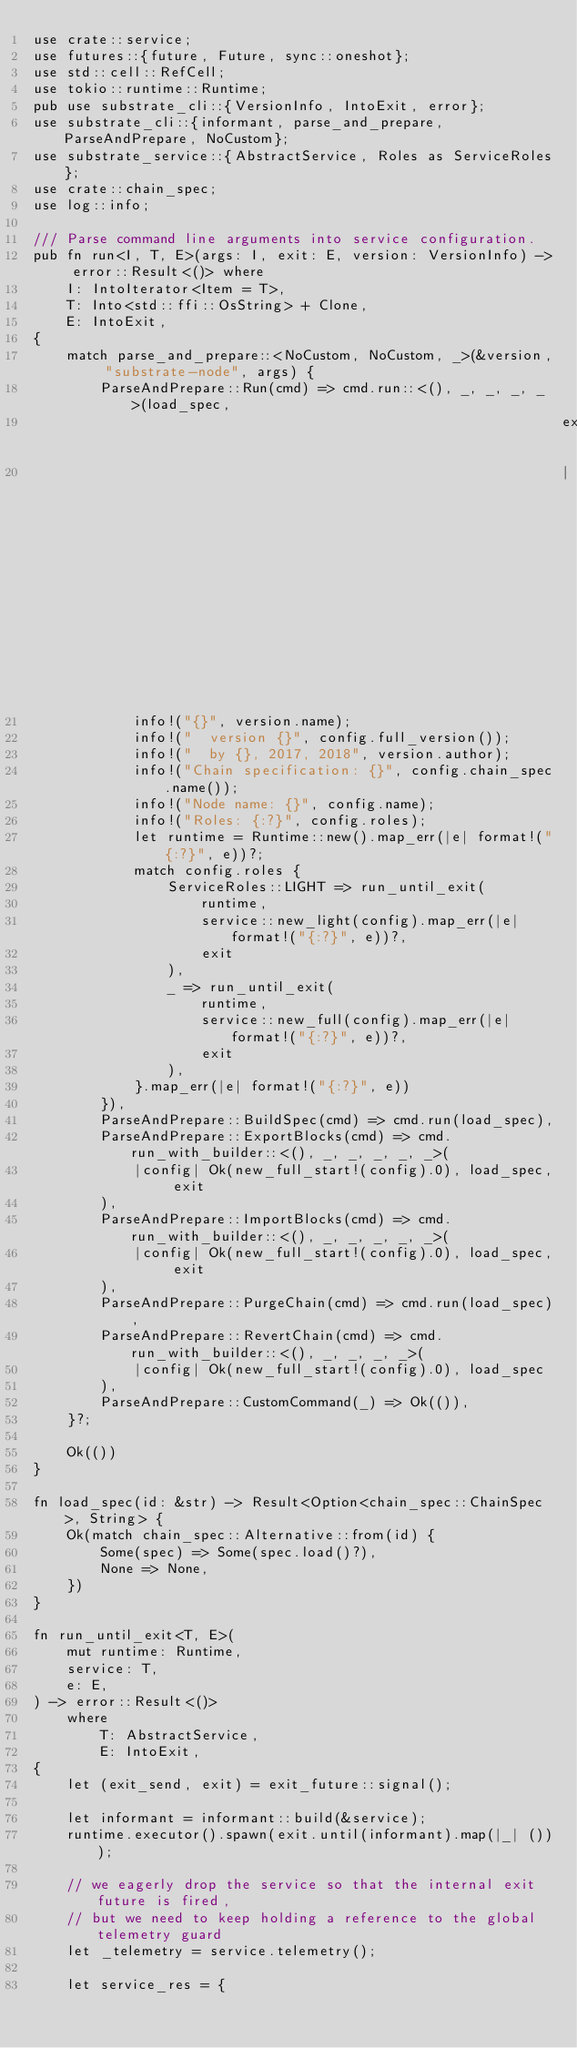<code> <loc_0><loc_0><loc_500><loc_500><_Rust_>use crate::service;
use futures::{future, Future, sync::oneshot};
use std::cell::RefCell;
use tokio::runtime::Runtime;
pub use substrate_cli::{VersionInfo, IntoExit, error};
use substrate_cli::{informant, parse_and_prepare, ParseAndPrepare, NoCustom};
use substrate_service::{AbstractService, Roles as ServiceRoles};
use crate::chain_spec;
use log::info;

/// Parse command line arguments into service configuration.
pub fn run<I, T, E>(args: I, exit: E, version: VersionInfo) -> error::Result<()> where
    I: IntoIterator<Item = T>,
    T: Into<std::ffi::OsString> + Clone,
    E: IntoExit,
{
    match parse_and_prepare::<NoCustom, NoCustom, _>(&version, "substrate-node", args) {
        ParseAndPrepare::Run(cmd) => cmd.run::<(), _, _, _, _>(load_spec,
                                                               exit,
                                                               |exit, _cli_args, _custom_args, config| {
            info!("{}", version.name);
            info!("  version {}", config.full_version());
            info!("  by {}, 2017, 2018", version.author);
            info!("Chain specification: {}", config.chain_spec.name());
            info!("Node name: {}", config.name);
            info!("Roles: {:?}", config.roles);
            let runtime = Runtime::new().map_err(|e| format!("{:?}", e))?;
            match config.roles {
                ServiceRoles::LIGHT => run_until_exit(
                    runtime,
                    service::new_light(config).map_err(|e| format!("{:?}", e))?,
                    exit
                ),
                _ => run_until_exit(
                    runtime,
                    service::new_full(config).map_err(|e| format!("{:?}", e))?,
                    exit
                ),
            }.map_err(|e| format!("{:?}", e))
        }),
        ParseAndPrepare::BuildSpec(cmd) => cmd.run(load_spec),
        ParseAndPrepare::ExportBlocks(cmd) => cmd.run_with_builder::<(), _, _, _, _, _>(
            |config| Ok(new_full_start!(config).0), load_spec, exit
        ),
        ParseAndPrepare::ImportBlocks(cmd) => cmd.run_with_builder::<(), _, _, _, _, _>(
            |config| Ok(new_full_start!(config).0), load_spec, exit
        ),
        ParseAndPrepare::PurgeChain(cmd) => cmd.run(load_spec),
        ParseAndPrepare::RevertChain(cmd) => cmd.run_with_builder::<(), _, _, _, _>(
            |config| Ok(new_full_start!(config).0), load_spec
        ),
        ParseAndPrepare::CustomCommand(_) => Ok(()),
    }?;

    Ok(())
}

fn load_spec(id: &str) -> Result<Option<chain_spec::ChainSpec>, String> {
    Ok(match chain_spec::Alternative::from(id) {
        Some(spec) => Some(spec.load()?),
        None => None,
    })
}

fn run_until_exit<T, E>(
    mut runtime: Runtime,
    service: T,
    e: E,
) -> error::Result<()>
    where
        T: AbstractService,
        E: IntoExit,
{
    let (exit_send, exit) = exit_future::signal();

    let informant = informant::build(&service);
    runtime.executor().spawn(exit.until(informant).map(|_| ()));

    // we eagerly drop the service so that the internal exit future is fired,
    // but we need to keep holding a reference to the global telemetry guard
    let _telemetry = service.telemetry();

    let service_res = {</code> 